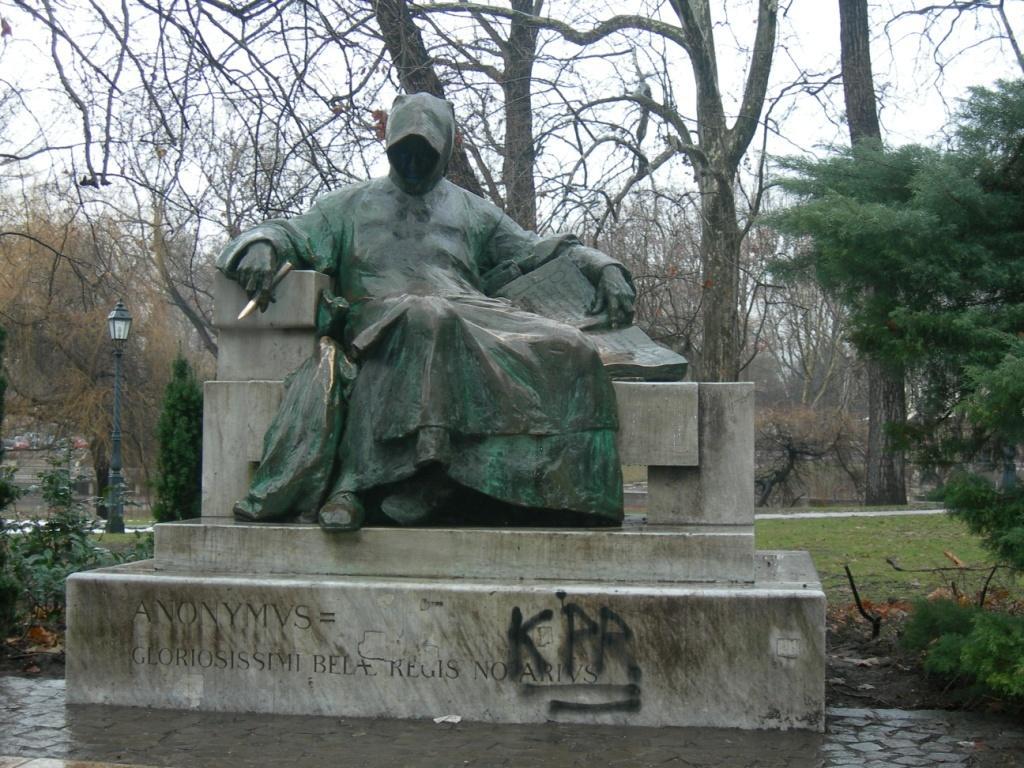Can you describe this image briefly? In this image there is a depiction of a person sitting and holding a book on the rock structure with some text on it, behind the statue there are trees, plants, grass, dry leaves on the surface, lamp and in the background there is the sky. 